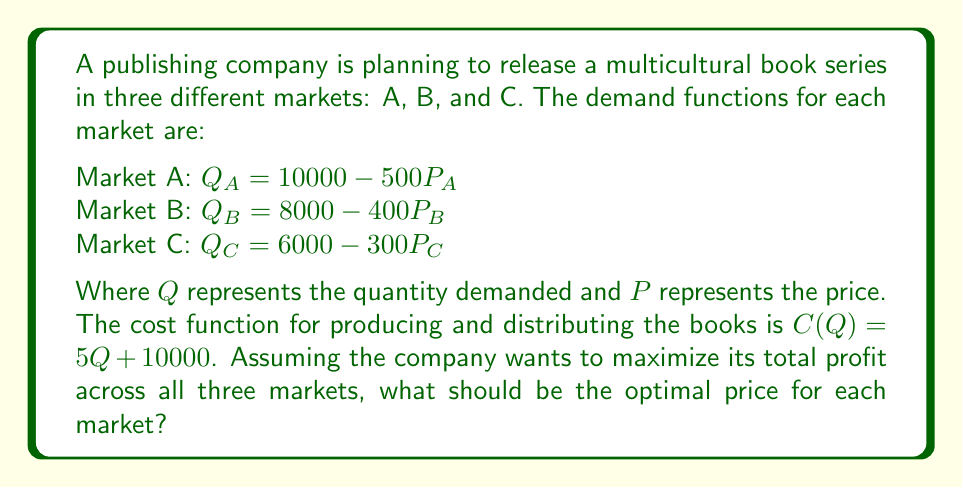Can you solve this math problem? To find the optimal pricing strategy, we need to maximize the total profit function. Let's follow these steps:

1) First, we need to express the profit function for each market:
   Profit = Revenue - Cost
   $\pi = PQ - C(Q)$

2) For each market, we can substitute the demand function into the profit equation:

   Market A: $\pi_A = P_A(10000 - 500P_A) - [5(10000 - 500P_A) + 10000]$
   Market B: $\pi_B = P_B(8000 - 400P_B) - [5(8000 - 400P_B) + 10000]$
   Market C: $\pi_C = P_C(6000 - 300P_C) - [5(6000 - 300P_C) + 10000]$

3) The total profit is the sum of profits from all markets:
   $\pi_{total} = \pi_A + \pi_B + \pi_C$

4) To maximize profit, we need to find the derivative of each profit function with respect to its price and set it to zero:

   For Market A: $\frac{d\pi_A}{dP_A} = 10000 - 1000P_A + 2500 = 0$
                 $12500 - 1000P_A = 0$
                 $P_A = 12.5$

   For Market B: $\frac{d\pi_B}{dP_B} = 8000 - 800P_B + 2000 = 0$
                 $10000 - 800P_B = 0$
                 $P_B = 12.5$

   For Market C: $\frac{d\pi_C}{dP_C} = 6000 - 600P_C + 1500 = 0$
                 $7500 - 600P_C = 0$
                 $P_C = 12.5$

5) We can verify that these critical points maximize profit by checking the second derivative (which is negative in all cases, confirming a maximum).

Therefore, the optimal price for each market is $12.5.
Answer: $P_A = P_B = P_C = 12.5$ 